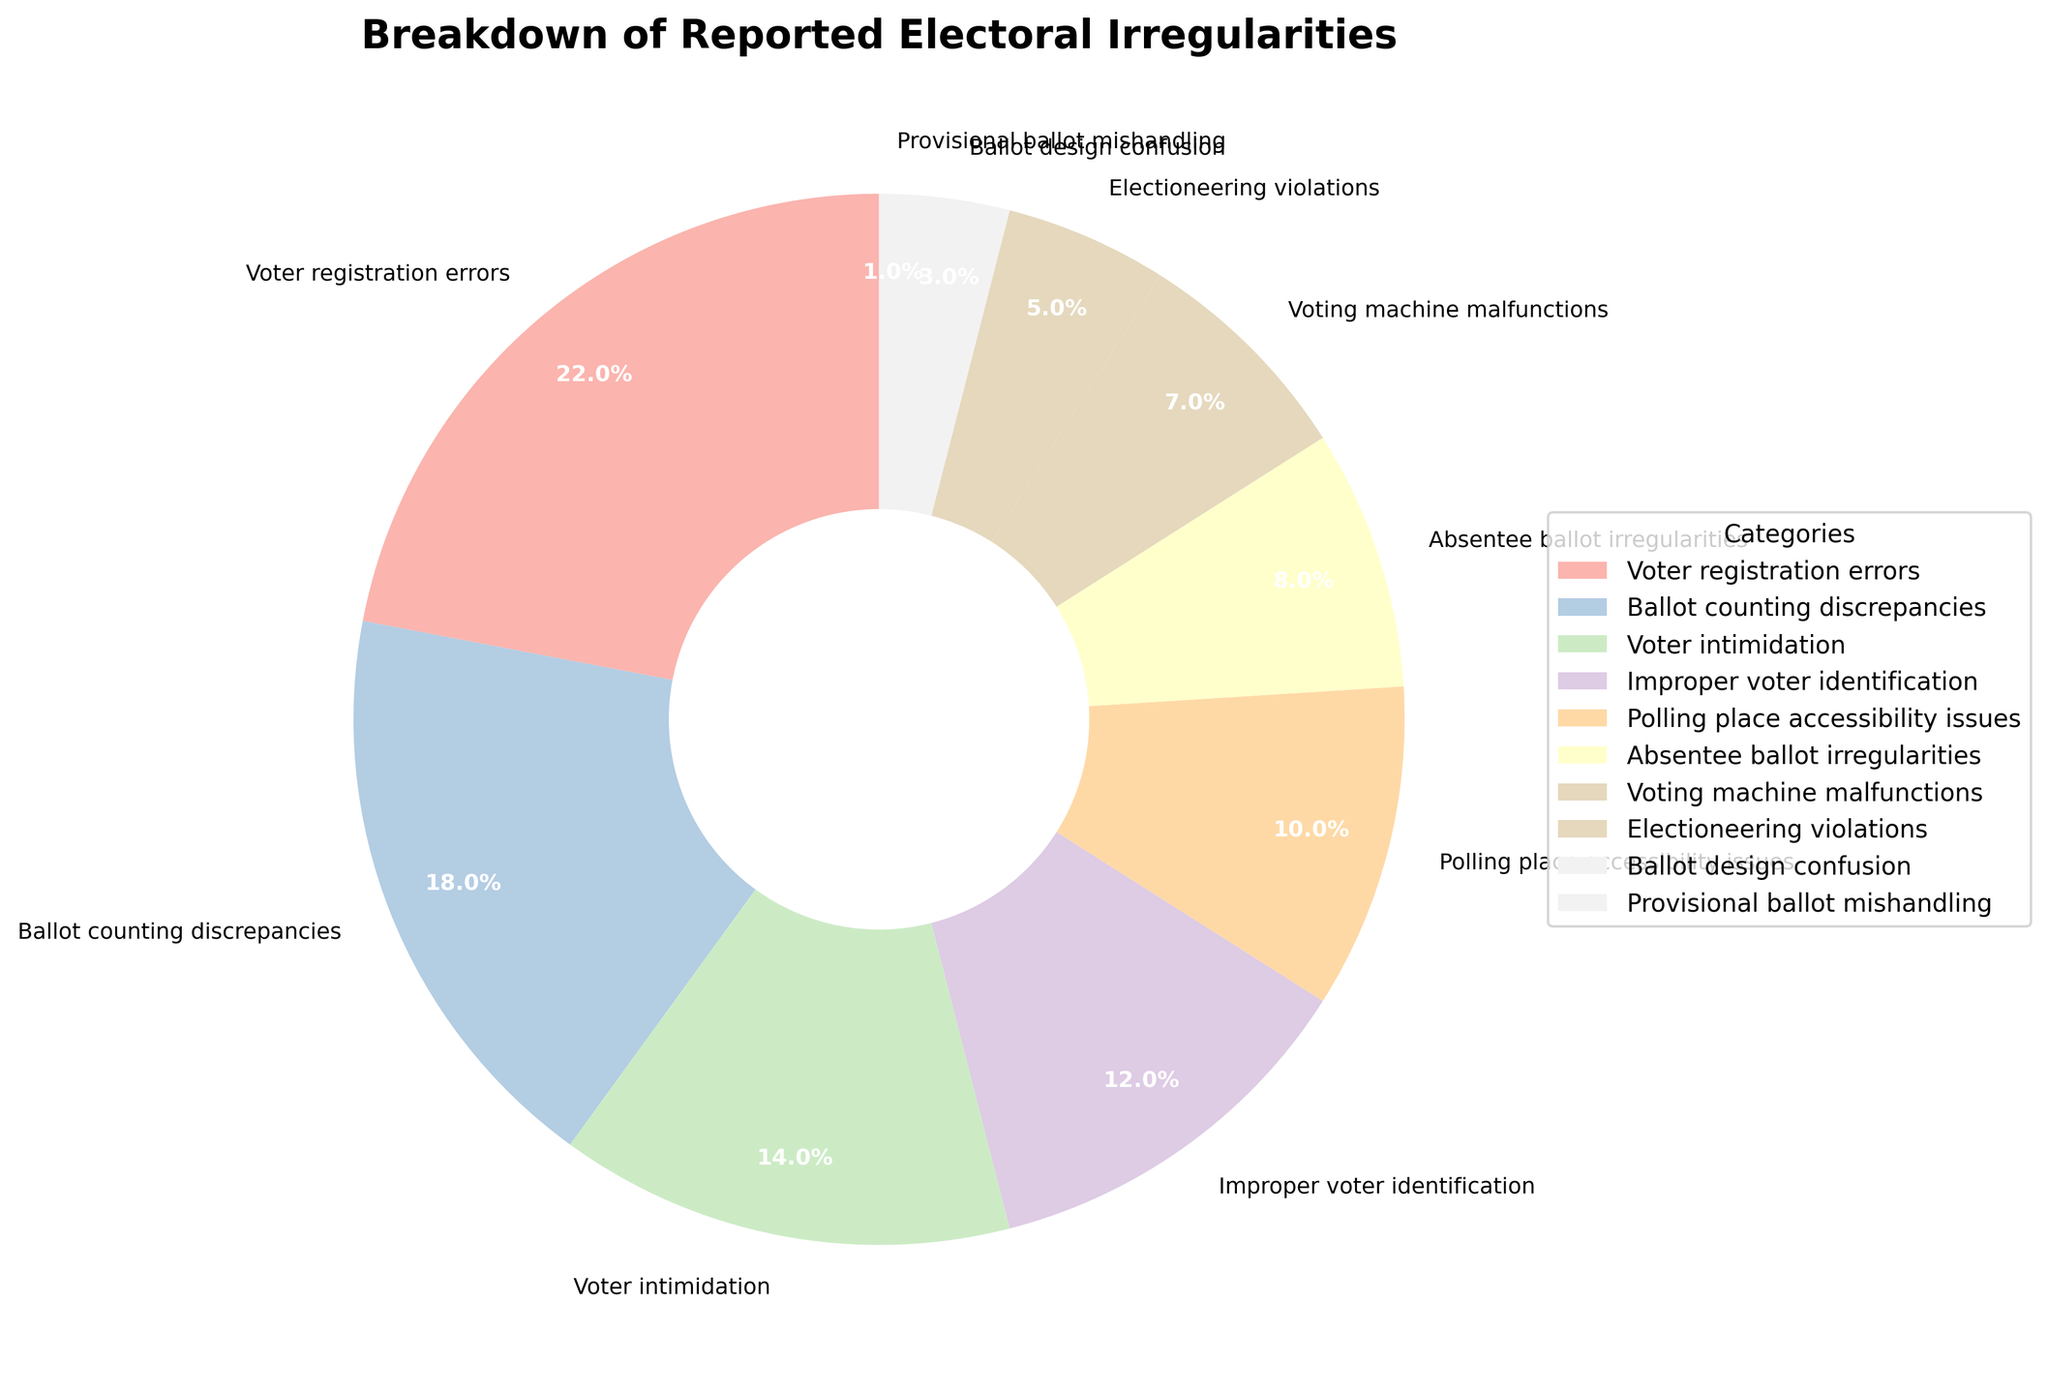Which category has the highest percentage of reported electoral irregularities? The category with the highest percentage will be the largest slice in the pie chart. Voter registration errors have 22%, which is the highest percentage.
Answer: Voter registration errors What is the total percentage of irregularities for ballot-related issues (Ballot counting discrepancies and Ballot design confusion)? Sum the percentages of all ballot-related issues: Ballot counting discrepancies (18%) + Ballot design confusion (3%) = 21%.
Answer: 21% Which category reports fewer irregularities: Voter intimidation or Voting machine malfunctions? Compare the two percentages: Voter intimidation (14%) and Voting machine malfunctions (7%). Since 7% is less than 14%, Voting machine malfunctions have fewer reported irregularities.
Answer: Voting machine malfunctions What is the combined percentage of irregularities due to absentee ballots and provisional ballots? Sum the percentages for Absentee ballot irregularities (8%) and Provisional ballot mishandling (1%): 8% + 1% = 9%.
Answer: 9% How many categories have a percentage of 10% or more? Count the number of categories individually having a percentage of 10% or more: Voter registration errors (22%), Ballot counting discrepancies (18%), Voter intimidation (14%), and Improper voter identification (12%). This gives a total of 4 categories.
Answer: 4 Between Polling place accessibility issues and Improper voter identification, which category has a lower percentage, and by how much? Polling place accessibility issues have 10% irregularities, and Improper voter identification has 12%. The difference is 12% - 10% = 2%. Thus, Polling place accessibility issues have a lower percentage by 2%.
Answer: Polling place accessibility issues by 2% What percentage of irregularities falls under Electioneering violations, Voting machine malfunctions, and Ballot design confusion combined? Sum the percentages of these three categories: Electioneering violations (5%), Voting machine malfunctions (7%), and Ballot design confusion (3%). So, 5% + 7% + 3% = 15%.
Answer: 15% Which category reports more irregularities, Polling place accessibility issues or Absentee ballot irregularities, and by what margin? Polling place accessibility issues (10%) have more reported irregularities compared to Absentee ballot irregularities (8%). The margin is 10% - 8% = 2%.
Answer: Polling place accessibility issues by 2% What is the average percentage of the four least frequent categories in the data? The four least frequent categories are Provisional ballot mishandling (1%), Ballot design confusion (3%), Electioneering violations (5%), and Voting machine malfunctions (7%). Their average is calculated as (1% + 3% + 5% + 7%) / 4 = 4%.
Answer: 4% 